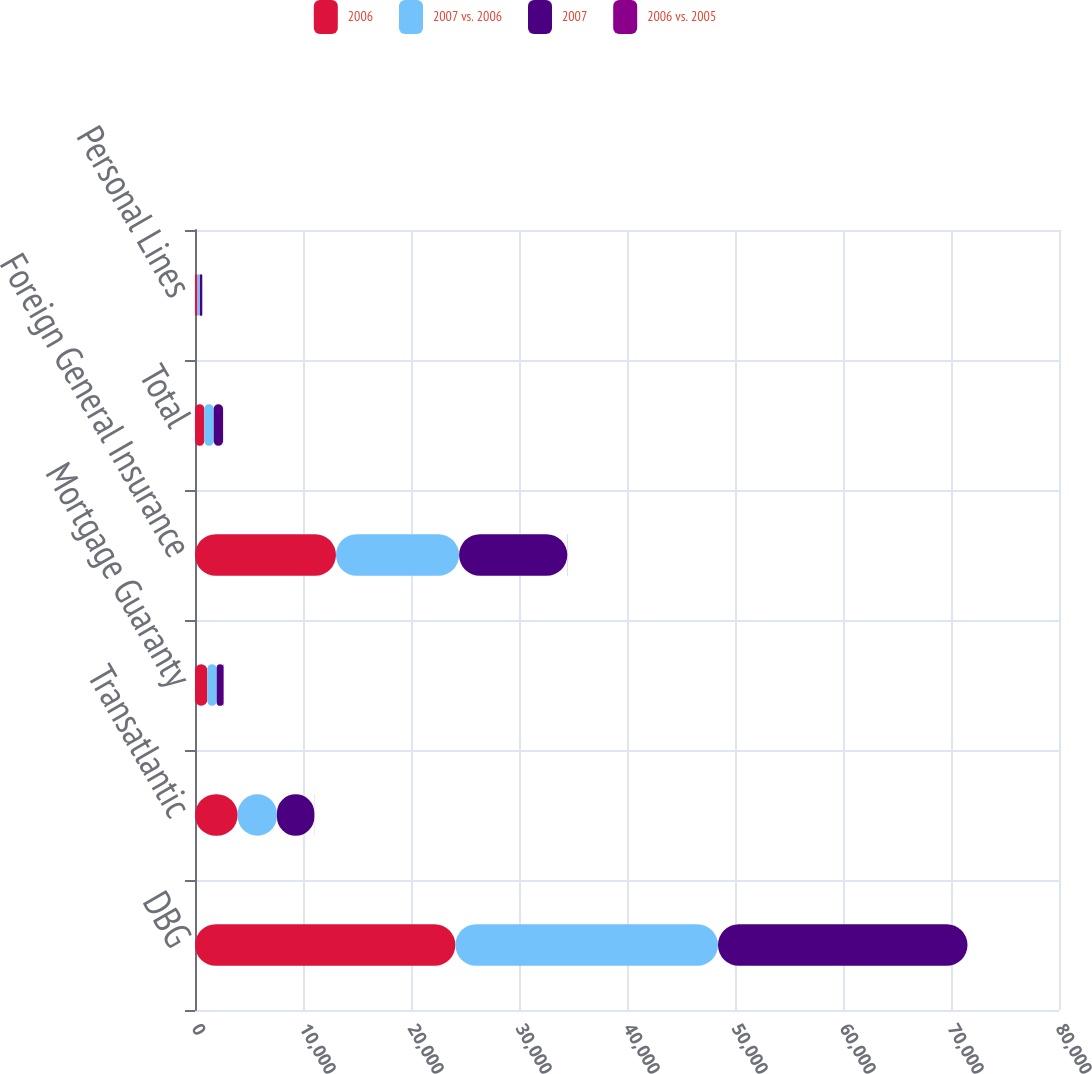Convert chart. <chart><loc_0><loc_0><loc_500><loc_500><stacked_bar_chart><ecel><fcel>DBG<fcel>Transatlantic<fcel>Mortgage Guaranty<fcel>Foreign General Insurance<fcel>Total<fcel>Personal Lines<nl><fcel>2006<fcel>24112<fcel>3953<fcel>1143<fcel>13051<fcel>866<fcel>231<nl><fcel>2007 vs. 2006<fcel>24312<fcel>3633<fcel>866<fcel>11401<fcel>866<fcel>225<nl><fcel>2007<fcel>23104<fcel>3466<fcel>628<fcel>10021<fcel>866<fcel>217<nl><fcel>2006 vs. 2005<fcel>1<fcel>9<fcel>32<fcel>14<fcel>5<fcel>3<nl></chart> 